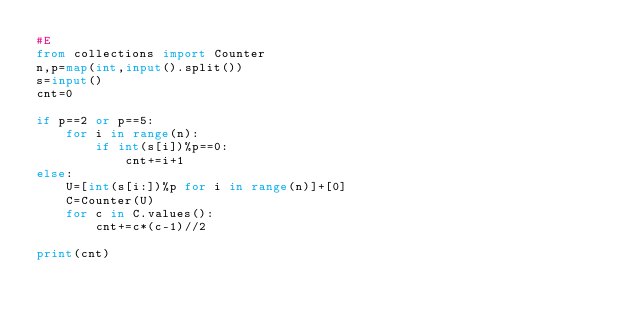Convert code to text. <code><loc_0><loc_0><loc_500><loc_500><_Python_>#E
from collections import Counter
n,p=map(int,input().split())
s=input()
cnt=0

if p==2 or p==5:
    for i in range(n):
        if int(s[i])%p==0:
            cnt+=i+1
else:
    U=[int(s[i:])%p for i in range(n)]+[0]
    C=Counter(U)
    for c in C.values():
        cnt+=c*(c-1)//2

print(cnt)</code> 